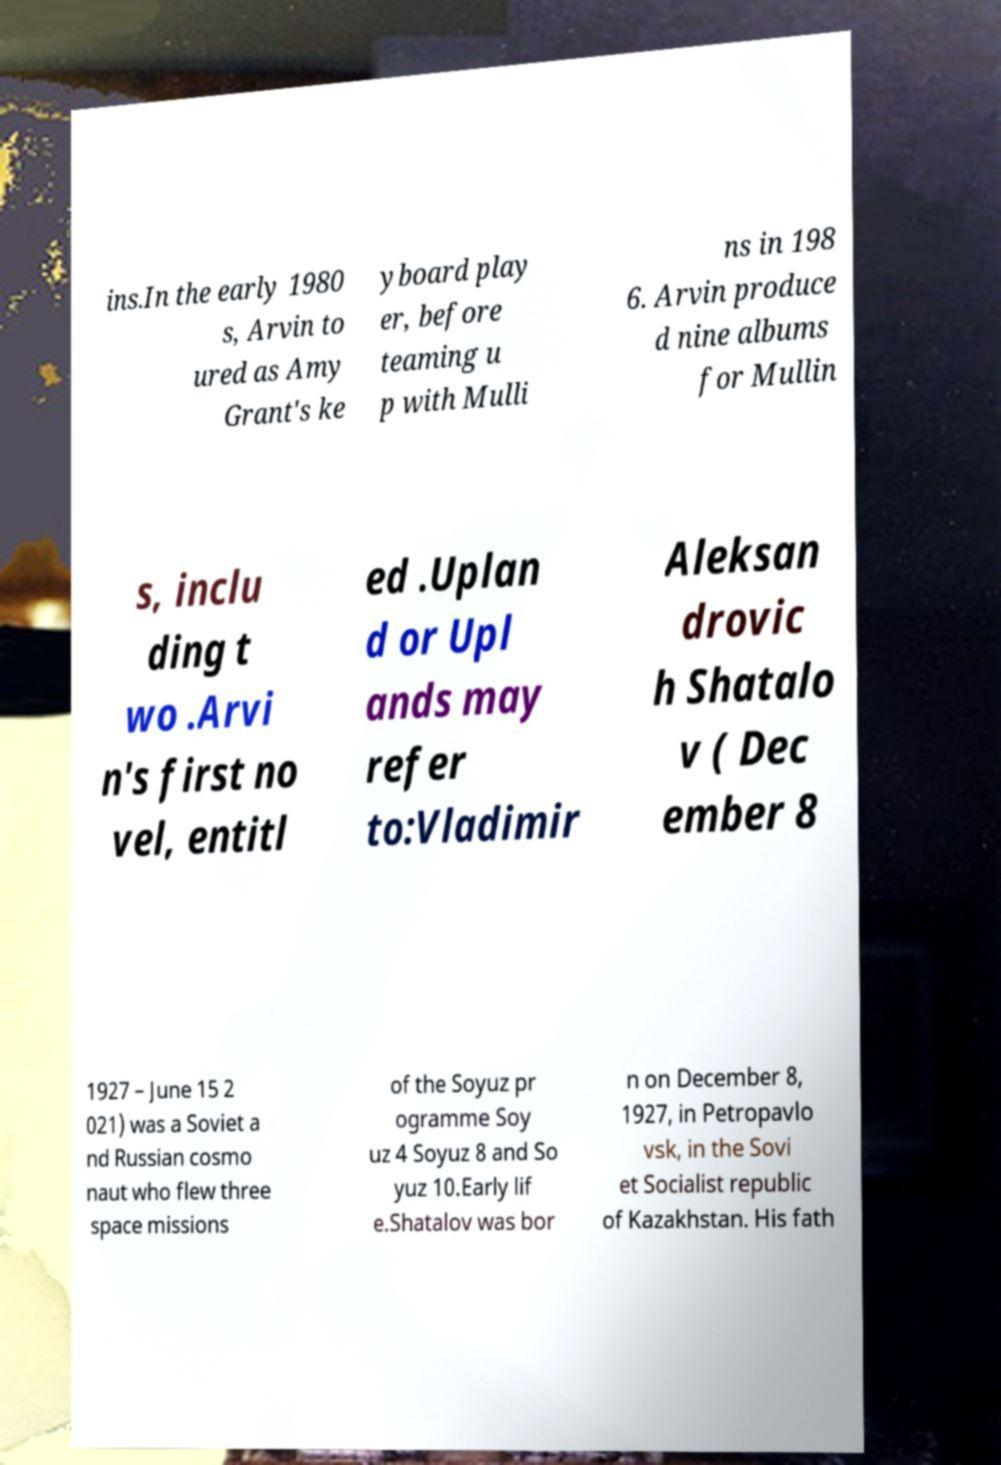Could you assist in decoding the text presented in this image and type it out clearly? ins.In the early 1980 s, Arvin to ured as Amy Grant's ke yboard play er, before teaming u p with Mulli ns in 198 6. Arvin produce d nine albums for Mullin s, inclu ding t wo .Arvi n's first no vel, entitl ed .Uplan d or Upl ands may refer to:Vladimir Aleksan drovic h Shatalo v ( Dec ember 8 1927 – June 15 2 021) was a Soviet a nd Russian cosmo naut who flew three space missions of the Soyuz pr ogramme Soy uz 4 Soyuz 8 and So yuz 10.Early lif e.Shatalov was bor n on December 8, 1927, in Petropavlo vsk, in the Sovi et Socialist republic of Kazakhstan. His fath 